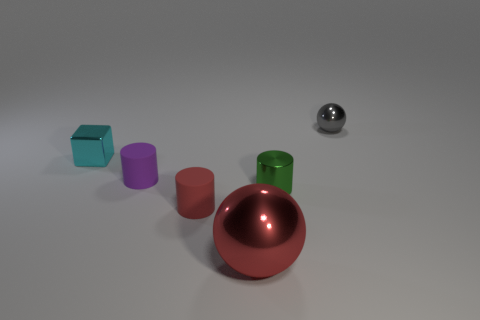How many cyan metallic things are the same size as the purple thing? There is one cyan metallic object that is the same size as the purple cylindrical object. Both appear to be identical in height and width, reflecting similar dimensions and proportions. 